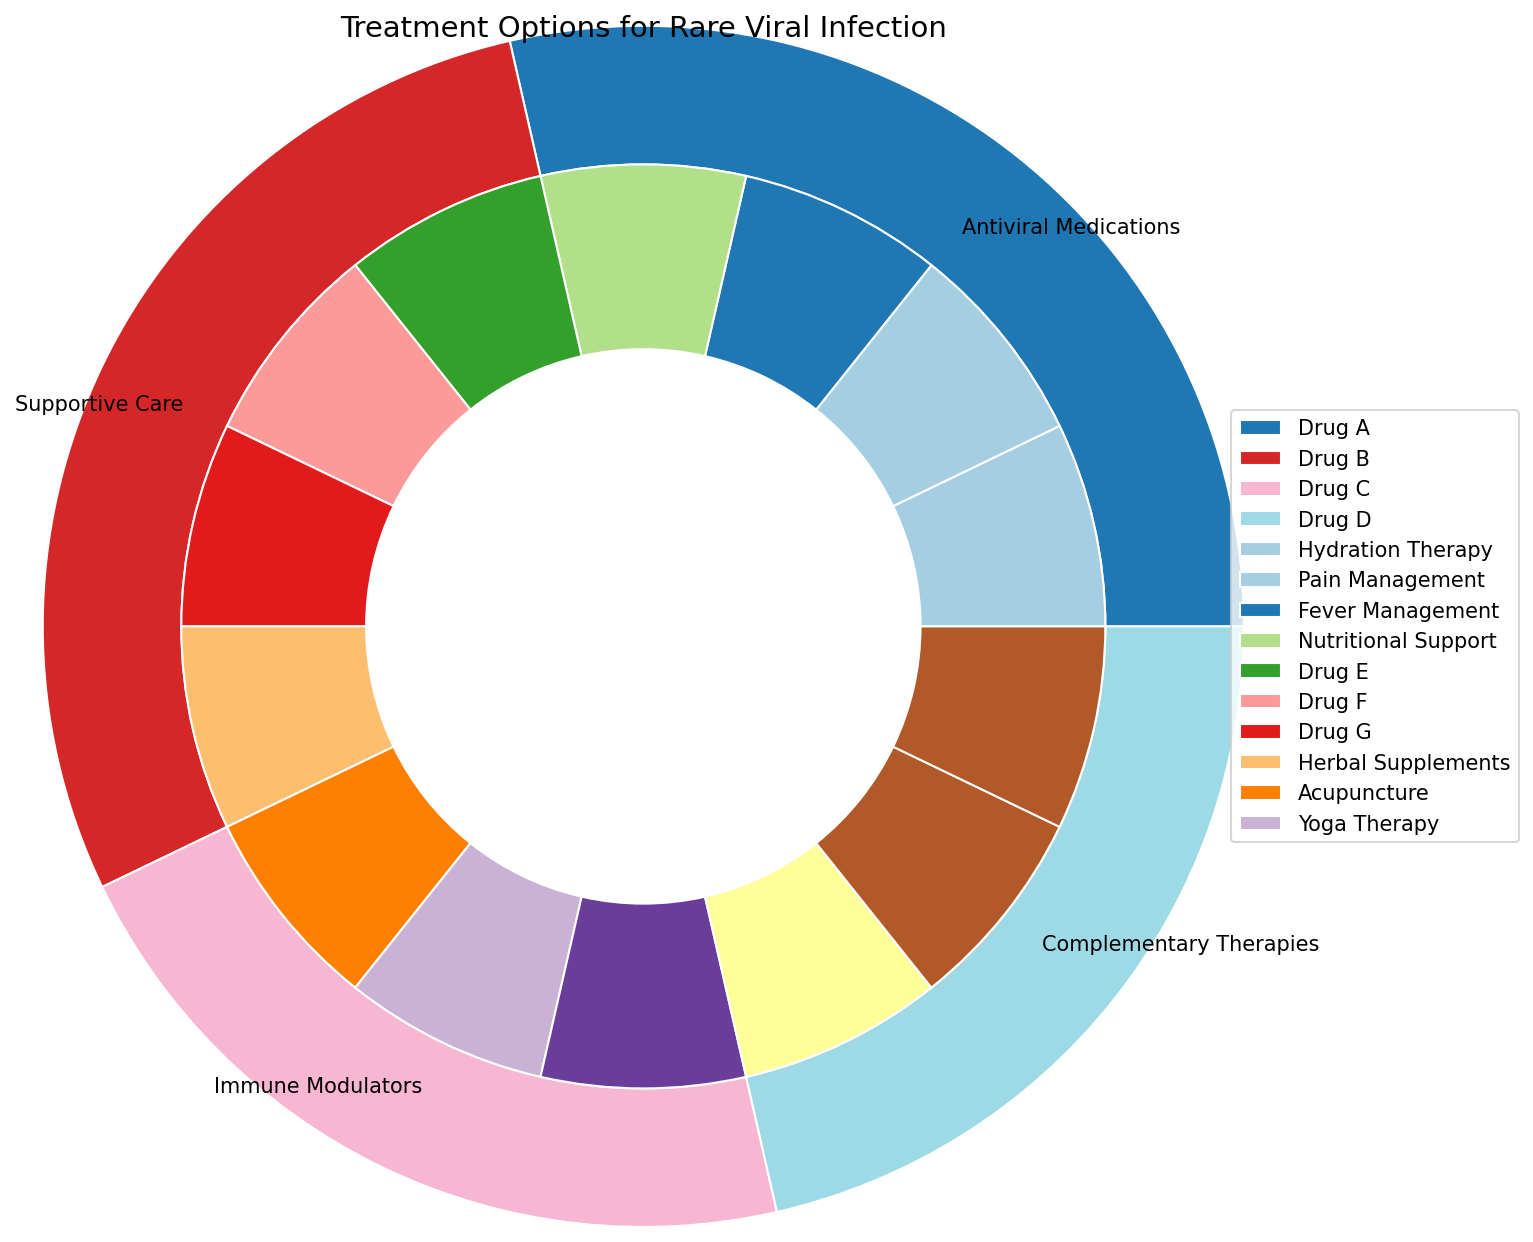What's the total number of treatment options available? Look at the individual labels for treatment options in the inner circle. Counting them gives us the total number of options. There are 3 (Antiviral Medications) + 4 (Supportive Care) + 3 (Immune Modulators) + 3 (Complementary Therapies) = 13 treatment options in total.
Answer: 13 Which treatment category has the most individual treatment options? Compare the number of treatment options in each category segment of the outer circle. Supportive Care has 4 options, while others have fewer.
Answer: Supportive Care Are there more antiviral medications or immune modulators? Count the individual treatment options in each category. Antiviral Medications have 4 options (Drug A, B, C, D), and Immune Modulators have 3 options (Drug E, F, G).
Answer: More antiviral medications What percentage of the total treatment options does Complementary Therapies represent? There are 3 Complementary Therapies out of 13 total treatment options. Calculate (3/13) * 100%.
Answer: Approximately 23% If you combine Antiviral Medications and Complementary Therapies, do they outnumber Supportive Care treatment options? Antiviral Medications have 4 options and Complementary Therapies have 3, totaling 7. Supportive Care has 4 options. 7 > 4, so yes, they do outnumber.
Answer: Yes What color represents Supportive Care treatments in the outer circle? Look at the outer circle and identify the segment labeled "Supportive Care." The corresponding color for this category segment is visually evident as yellow.
Answer: Yellow What's the most common type of treatment option by count? Visually check which category has the largest share in the outer circle. Supportive Care has the most categories (4 options).
Answer: Supportive Care List all the treatment options available under Immune Modulators. Examine the inner circle section corresponding to Immune Modulators. The treatments listed are Drug E, Drug F, and Drug G.
Answer: Drug E, Drug F, Drug G Which treatment category has the smallest section in the outer circle? Visually compare the segments of the outer circle. Complementary Therapies and Immune Modulators have equal but smaller segments compared to others, due to fewer options.
Answer: Immune Modulators and Complementary Therapies 